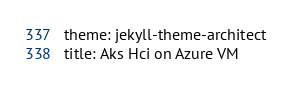Convert code to text. <code><loc_0><loc_0><loc_500><loc_500><_YAML_>theme: jekyll-theme-architect
title: Aks Hci on Azure VM</code> 